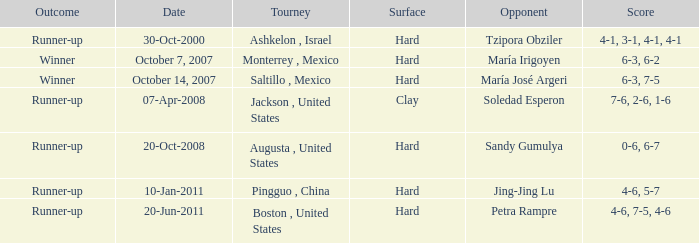Who was the opponent with a score of 4-6, 7-5, 4-6? Petra Rampre. 